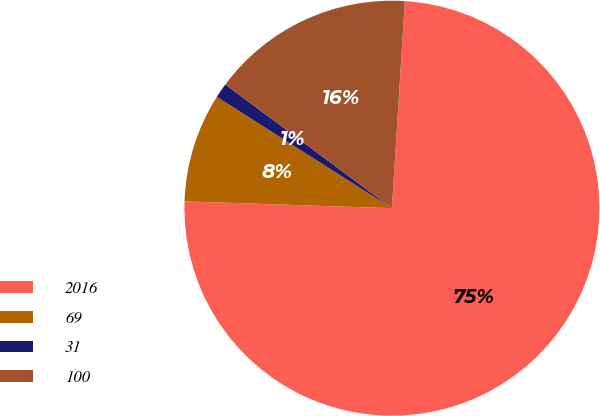Convert chart to OTSL. <chart><loc_0><loc_0><loc_500><loc_500><pie_chart><fcel>2016<fcel>69<fcel>31<fcel>100<nl><fcel>74.54%<fcel>8.49%<fcel>1.15%<fcel>15.83%<nl></chart> 